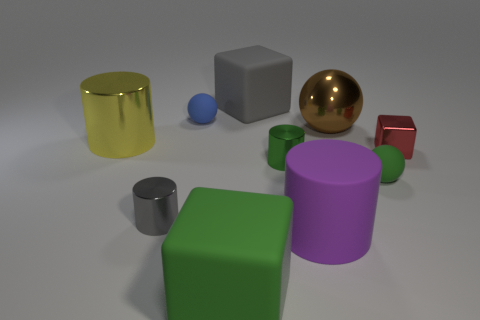Is there any other thing that has the same material as the yellow thing?
Your response must be concise. Yes. Are the tiny cube and the large yellow thing made of the same material?
Your response must be concise. Yes. What number of other things are the same color as the large shiny ball?
Give a very brief answer. 0. There is a gray thing that is to the left of the blue matte ball; what shape is it?
Make the answer very short. Cylinder. How many things are large yellow shiny cylinders or gray metal balls?
Provide a short and direct response. 1. Do the brown metallic sphere and the rubber cube behind the big yellow thing have the same size?
Provide a short and direct response. Yes. What number of other objects are there of the same material as the big gray cube?
Offer a terse response. 4. What number of things are either gray things to the left of the green cube or rubber balls behind the green sphere?
Offer a very short reply. 2. What is the material of the small red object that is the same shape as the large gray thing?
Keep it short and to the point. Metal. Is there a rubber block?
Your answer should be very brief. Yes. 